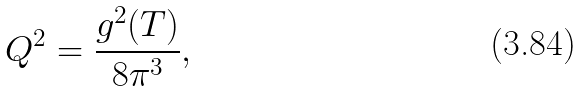Convert formula to latex. <formula><loc_0><loc_0><loc_500><loc_500>Q ^ { 2 } = \frac { g ^ { 2 } ( T ) } { 8 \pi ^ { 3 } } ,</formula> 